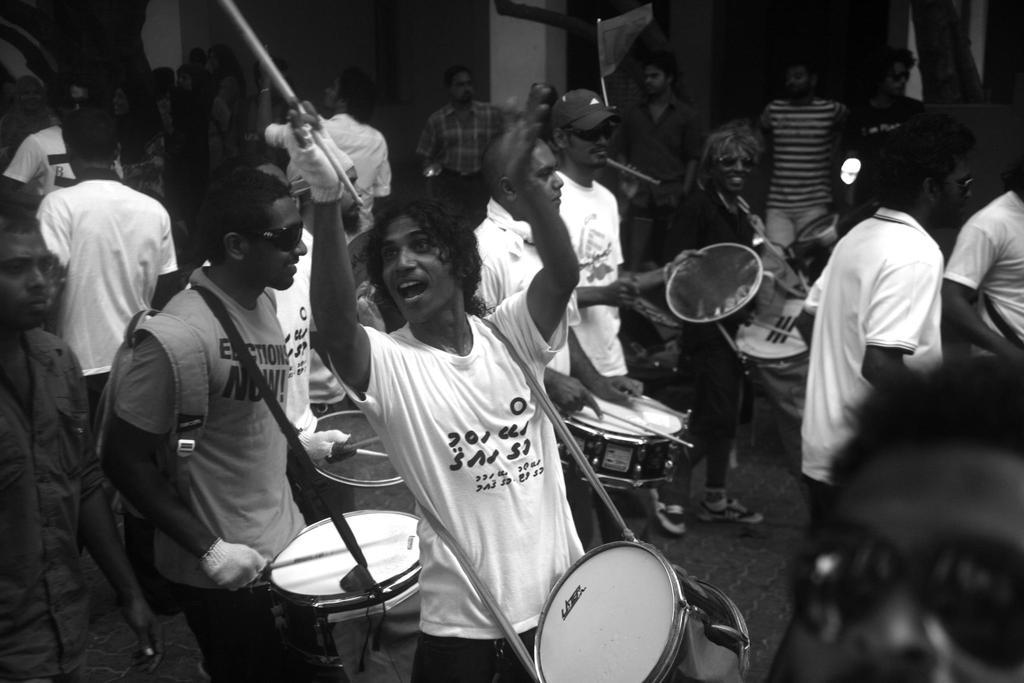How many people are playing musical instruments in the image? Multiple persons are playing musical instruments in the image. What is the person with the drumstick holding? The person with the drumstick is holding a drumstick. What is the person with the drumstick wearing on their hands? The person with the drumstick is wearing gloves. What instrument is the person with the drumstick playing? The person with the drumstick is playing drums. What is another person wearing in the image? Another person is wearing a bag. What type of spy equipment can be seen in the image? There is no spy equipment present in the image. What kind of space-related objects can be seen in the image? There are no space-related objects present in the image. 